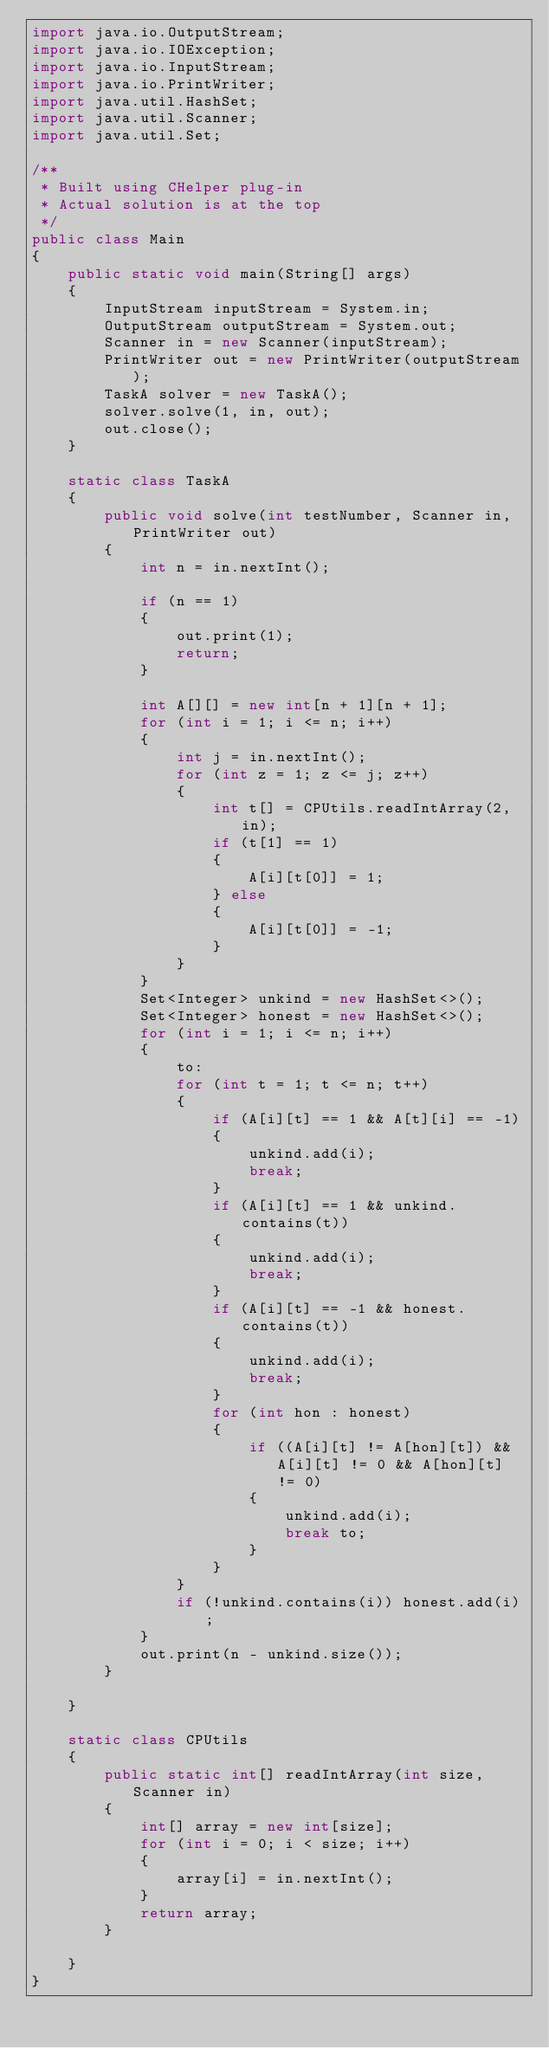<code> <loc_0><loc_0><loc_500><loc_500><_Java_>import java.io.OutputStream;
import java.io.IOException;
import java.io.InputStream;
import java.io.PrintWriter;
import java.util.HashSet;
import java.util.Scanner;
import java.util.Set;

/**
 * Built using CHelper plug-in
 * Actual solution is at the top
 */
public class Main
{
    public static void main(String[] args)
    {
        InputStream inputStream = System.in;
        OutputStream outputStream = System.out;
        Scanner in = new Scanner(inputStream);
        PrintWriter out = new PrintWriter(outputStream);
        TaskA solver = new TaskA();
        solver.solve(1, in, out);
        out.close();
    }

    static class TaskA
    {
        public void solve(int testNumber, Scanner in, PrintWriter out)
        {
            int n = in.nextInt();

            if (n == 1)
            {
                out.print(1);
                return;
            }

            int A[][] = new int[n + 1][n + 1];
            for (int i = 1; i <= n; i++)
            {
                int j = in.nextInt();
                for (int z = 1; z <= j; z++)
                {
                    int t[] = CPUtils.readIntArray(2, in);
                    if (t[1] == 1)
                    {
                        A[i][t[0]] = 1;
                    } else
                    {
                        A[i][t[0]] = -1;
                    }
                }
            }
            Set<Integer> unkind = new HashSet<>();
            Set<Integer> honest = new HashSet<>();
            for (int i = 1; i <= n; i++)
            {
                to:
                for (int t = 1; t <= n; t++)
                {
                    if (A[i][t] == 1 && A[t][i] == -1)
                    {
                        unkind.add(i);
                        break;
                    }
                    if (A[i][t] == 1 && unkind.contains(t))
                    {
                        unkind.add(i);
                        break;
                    }
                    if (A[i][t] == -1 && honest.contains(t))
                    {
                        unkind.add(i);
                        break;
                    }
                    for (int hon : honest)
                    {
                        if ((A[i][t] != A[hon][t]) && A[i][t] != 0 && A[hon][t] != 0)
                        {
                            unkind.add(i);
                            break to;
                        }
                    }
                }
                if (!unkind.contains(i)) honest.add(i);
            }
            out.print(n - unkind.size());
        }

    }

    static class CPUtils
    {
        public static int[] readIntArray(int size, Scanner in)
        {
            int[] array = new int[size];
            for (int i = 0; i < size; i++)
            {
                array[i] = in.nextInt();
            }
            return array;
        }

    }
}

</code> 